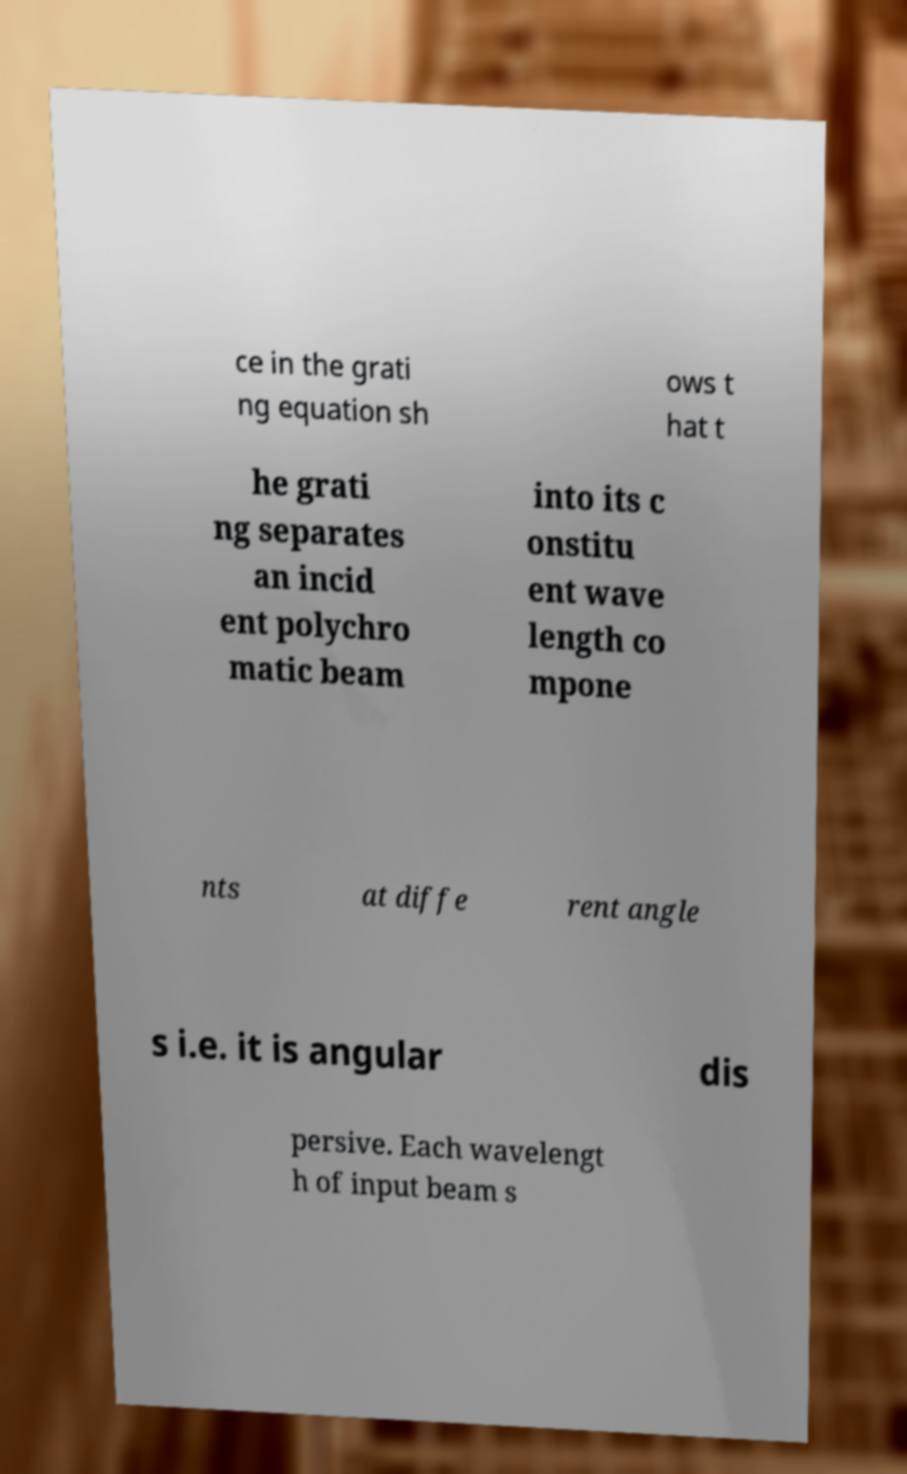For documentation purposes, I need the text within this image transcribed. Could you provide that? ce in the grati ng equation sh ows t hat t he grati ng separates an incid ent polychro matic beam into its c onstitu ent wave length co mpone nts at diffe rent angle s i.e. it is angular dis persive. Each wavelengt h of input beam s 